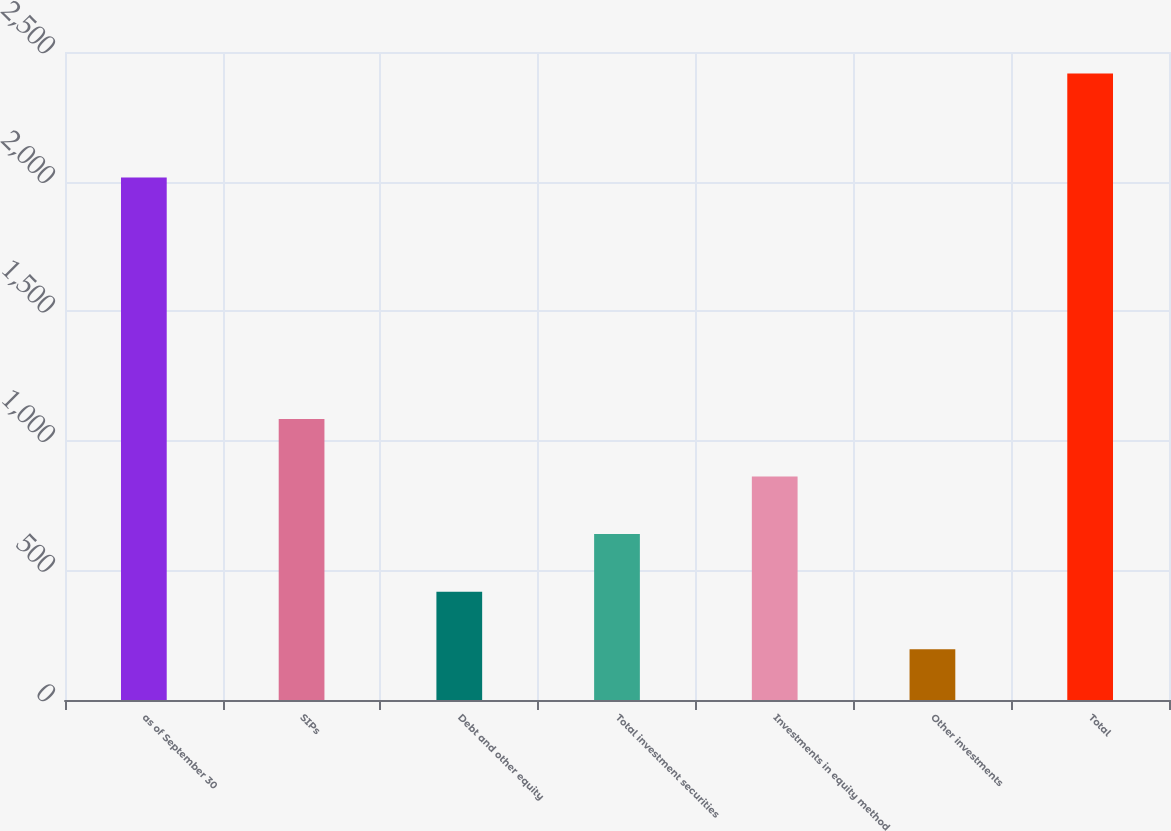<chart> <loc_0><loc_0><loc_500><loc_500><bar_chart><fcel>as of September 30<fcel>SIPs<fcel>Debt and other equity<fcel>Total investment securities<fcel>Investments in equity method<fcel>Other investments<fcel>Total<nl><fcel>2016<fcel>1084.18<fcel>417.97<fcel>640.04<fcel>862.11<fcel>195.9<fcel>2416.6<nl></chart> 